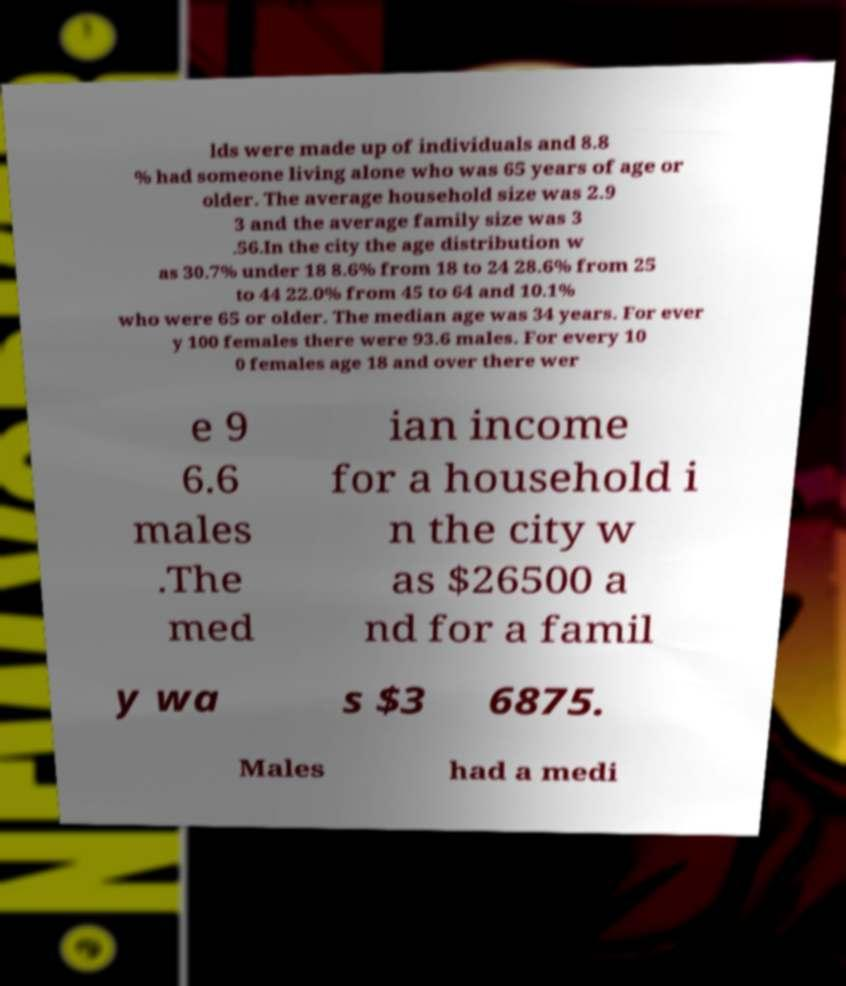I need the written content from this picture converted into text. Can you do that? lds were made up of individuals and 8.8 % had someone living alone who was 65 years of age or older. The average household size was 2.9 3 and the average family size was 3 .56.In the city the age distribution w as 30.7% under 18 8.6% from 18 to 24 28.6% from 25 to 44 22.0% from 45 to 64 and 10.1% who were 65 or older. The median age was 34 years. For ever y 100 females there were 93.6 males. For every 10 0 females age 18 and over there wer e 9 6.6 males .The med ian income for a household i n the city w as $26500 a nd for a famil y wa s $3 6875. Males had a medi 